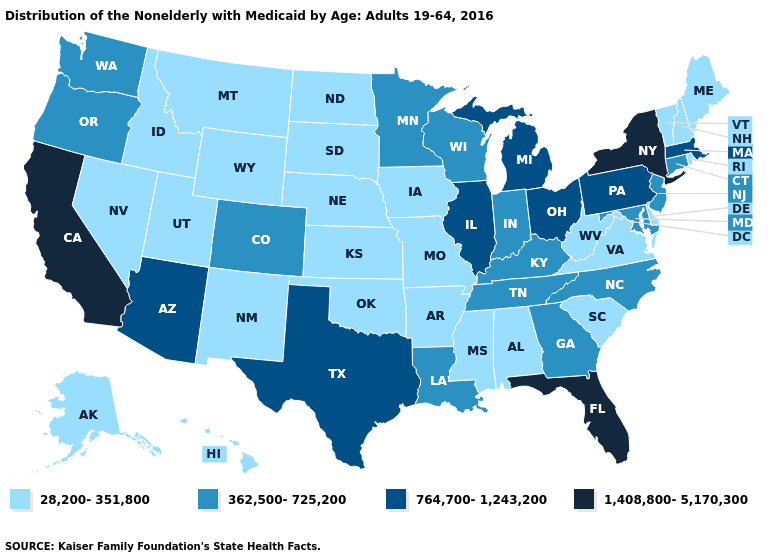Which states have the highest value in the USA?
Concise answer only. California, Florida, New York. What is the lowest value in states that border Illinois?
Concise answer only. 28,200-351,800. Does South Carolina have the lowest value in the South?
Give a very brief answer. Yes. Which states have the lowest value in the USA?
Keep it brief. Alabama, Alaska, Arkansas, Delaware, Hawaii, Idaho, Iowa, Kansas, Maine, Mississippi, Missouri, Montana, Nebraska, Nevada, New Hampshire, New Mexico, North Dakota, Oklahoma, Rhode Island, South Carolina, South Dakota, Utah, Vermont, Virginia, West Virginia, Wyoming. Name the states that have a value in the range 764,700-1,243,200?
Short answer required. Arizona, Illinois, Massachusetts, Michigan, Ohio, Pennsylvania, Texas. Among the states that border Connecticut , does Rhode Island have the highest value?
Quick response, please. No. Does Alabama have the lowest value in the USA?
Keep it brief. Yes. Among the states that border Wisconsin , does Michigan have the highest value?
Write a very short answer. Yes. Which states have the lowest value in the Northeast?
Keep it brief. Maine, New Hampshire, Rhode Island, Vermont. What is the value of Texas?
Write a very short answer. 764,700-1,243,200. Among the states that border Ohio , does West Virginia have the lowest value?
Give a very brief answer. Yes. Among the states that border North Carolina , does Virginia have the highest value?
Quick response, please. No. Which states hav the highest value in the South?
Answer briefly. Florida. What is the highest value in the MidWest ?
Write a very short answer. 764,700-1,243,200. 